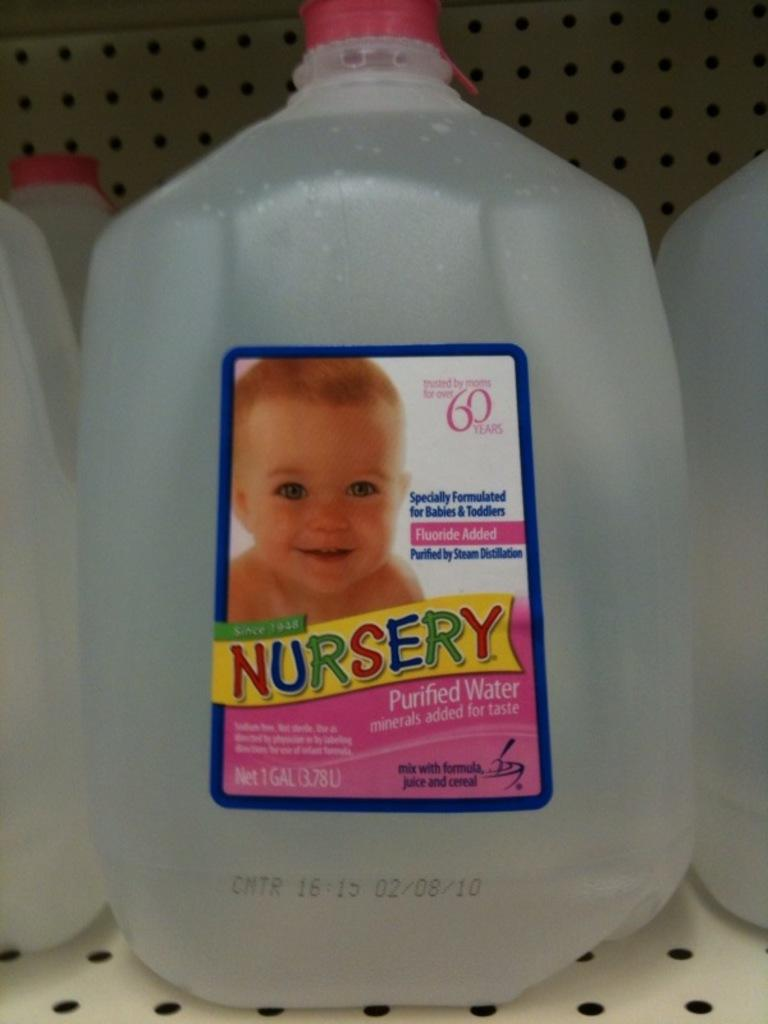What is on the bottle in the image? There is a sticker on the bottle. What is depicted on the sticker? The sticker has a baby image. What can be seen in the background of the image? There is an iron wall in the background of the image. What type of veil is draped over the baby in the image? There is no veil present in the image; the sticker only depicts a baby without any additional accessories or clothing. 